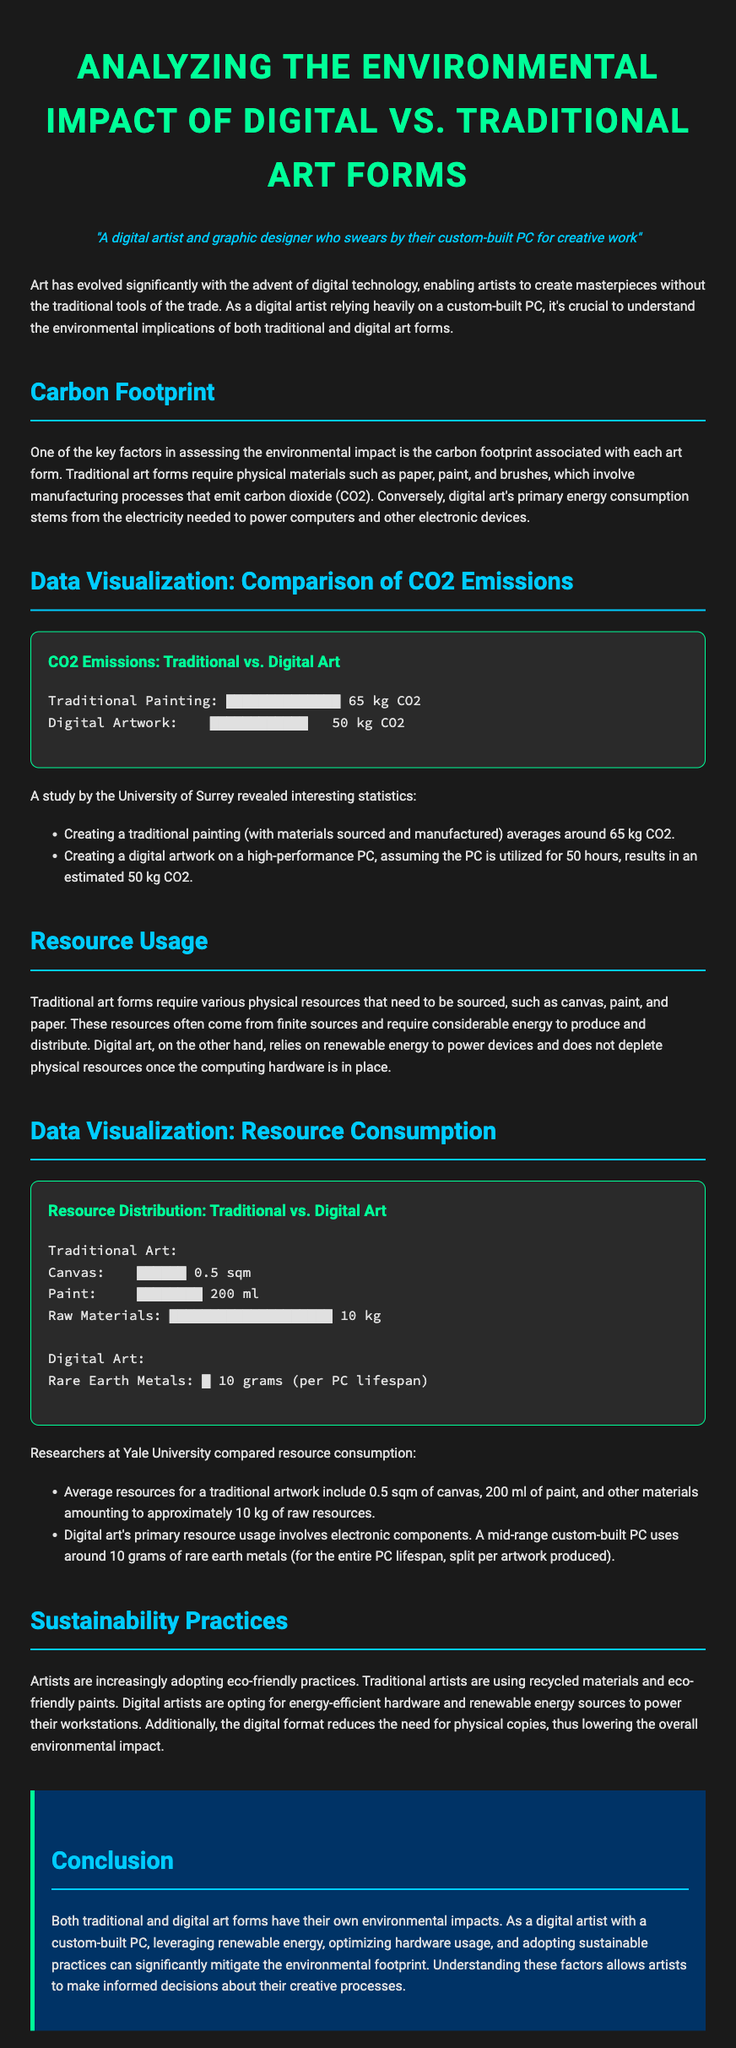What is the carbon footprint of traditional painting? The carbon footprint of creating a traditional painting averages around 65 kg CO2.
Answer: 65 kg CO2 What is the resource consumption for digital art in rare earth metals? Digital art's primary resource usage involves approximately 10 grams of rare earth metals for the entire PC lifespan, split per artwork produced.
Answer: 10 grams What carbon footprint does digital artwork produce? Creating a digital artwork on a high-performance PC results in an estimated 50 kg CO2.
Answer: 50 kg CO2 What materials are used for traditional art in terms of canvas area? Average resources for a traditional artwork include 0.5 sqm of canvas.
Answer: 0.5 sqm Which university conducted the study revealing the CO2 emissions for art forms? A study by the University of Surrey revealed interesting statistics regarding CO2 emissions.
Answer: University of Surrey How much paint is typically involved in traditional artwork? Average resources for a traditional artwork include 200 ml of paint.
Answer: 200 ml What is the sustainability practice mentioned for digital artists? Digital artists are opting for energy-efficient hardware and renewable energy sources to power their workstations.
Answer: Energy-efficient hardware What is the main benefit of digital art regarding physical copies? The digital format reduces the need for physical copies, thus lowering the overall environmental impact.
Answer: Reduces need for physical copies How much CO2 is emitted from traditional materials versus digital creation? Traditional painting emits 65 kg CO2, while digital artwork emits 50 kg CO2.
Answer: 65 kg vs. 50 kg CO2 